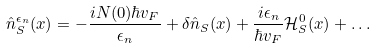<formula> <loc_0><loc_0><loc_500><loc_500>\hat { n } _ { S } ^ { \epsilon _ { n } } ( { x } ) = - \frac { i N ( 0 ) \hbar { v } _ { F } } { \epsilon _ { n } } + \delta \hat { n } _ { S } ( { x } ) + \frac { i \epsilon _ { n } } { \hbar { v } _ { F } } { \mathcal { H } } _ { S } ^ { 0 } ( { x } ) + \dots</formula> 